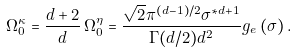<formula> <loc_0><loc_0><loc_500><loc_500>\Omega _ { 0 } ^ { \kappa } = \frac { d + 2 } { d } \, \Omega _ { 0 } ^ { \eta } = \frac { \sqrt { 2 } \pi ^ { ( d - 1 ) / 2 } \sigma ^ { \ast d + 1 } } { \Gamma ( d / 2 ) d ^ { 2 } } g _ { e } \left ( \sigma \right ) .</formula> 